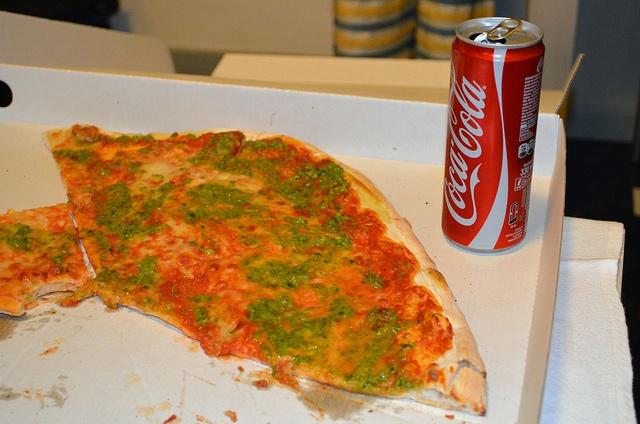Describe the objects in this image and their specific colors. I can see a pizza in black, olive, red, and tan tones in this image. 